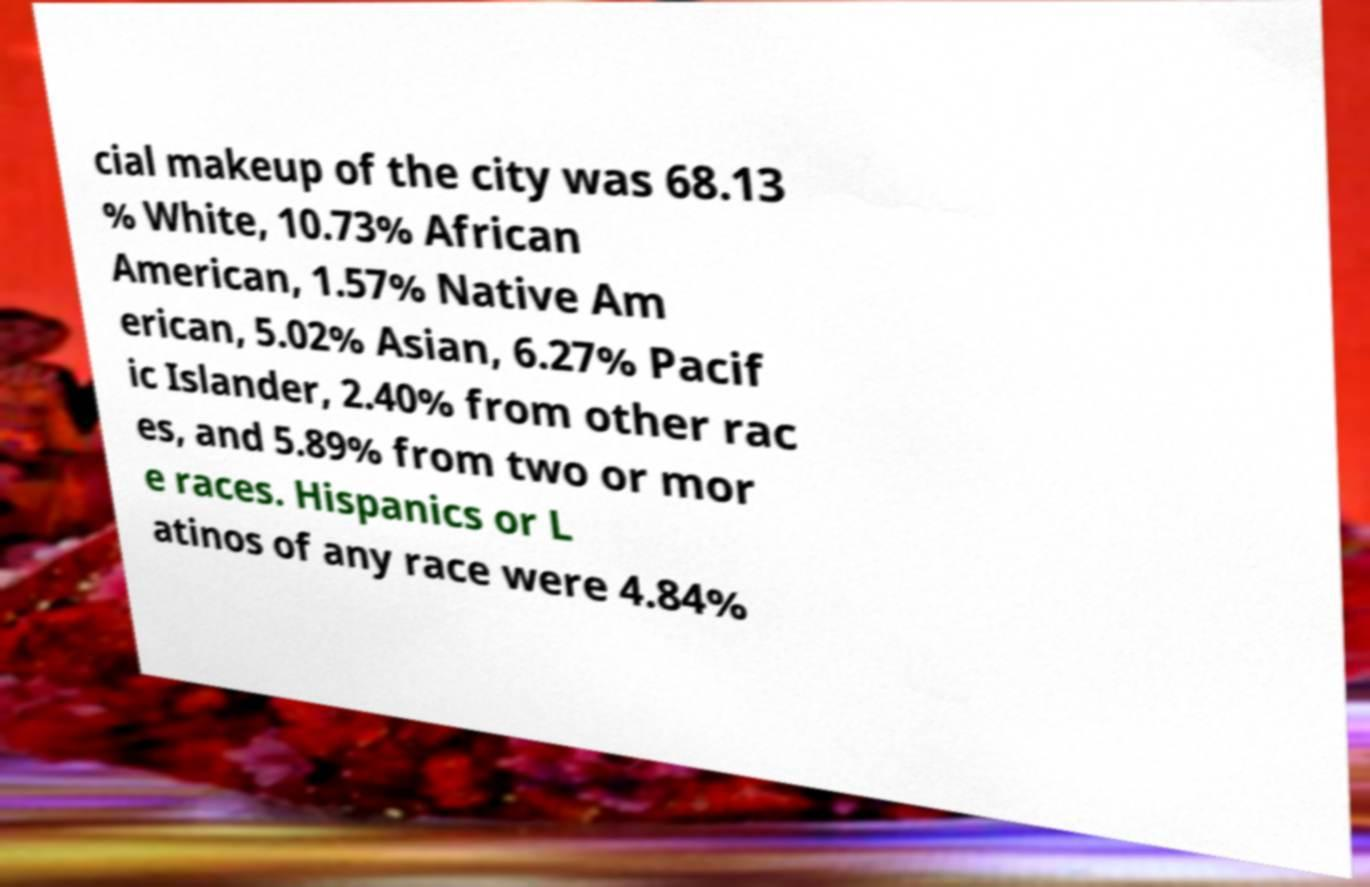Could you assist in decoding the text presented in this image and type it out clearly? cial makeup of the city was 68.13 % White, 10.73% African American, 1.57% Native Am erican, 5.02% Asian, 6.27% Pacif ic Islander, 2.40% from other rac es, and 5.89% from two or mor e races. Hispanics or L atinos of any race were 4.84% 